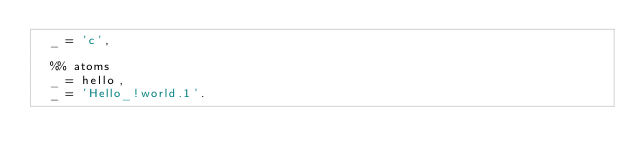Convert code to text. <code><loc_0><loc_0><loc_500><loc_500><_Erlang_>  _ = 'c',

  %% atoms
  _ = hello,
  _ = 'Hello_!world.1'.
</code> 